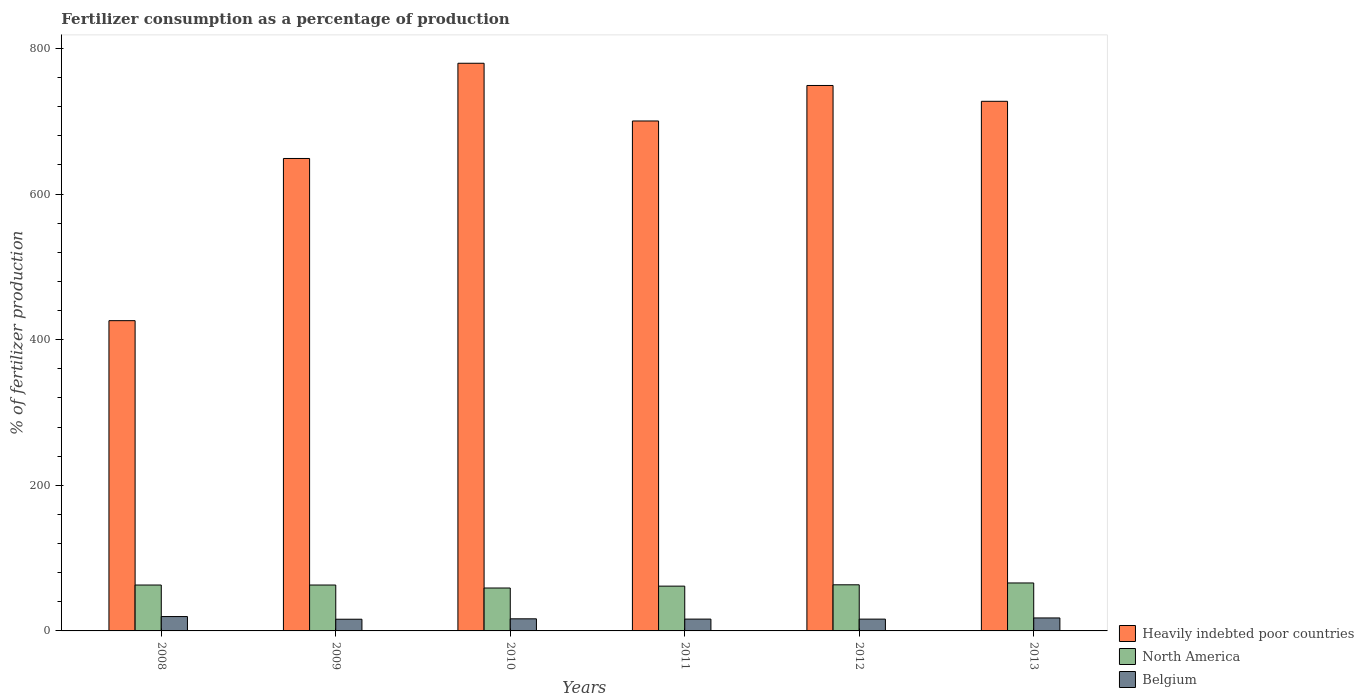How many groups of bars are there?
Make the answer very short. 6. Are the number of bars on each tick of the X-axis equal?
Offer a terse response. Yes. How many bars are there on the 2nd tick from the right?
Give a very brief answer. 3. What is the percentage of fertilizers consumed in Belgium in 2008?
Keep it short and to the point. 19.73. Across all years, what is the maximum percentage of fertilizers consumed in North America?
Ensure brevity in your answer.  65.86. Across all years, what is the minimum percentage of fertilizers consumed in Belgium?
Make the answer very short. 16.07. What is the total percentage of fertilizers consumed in Heavily indebted poor countries in the graph?
Give a very brief answer. 4031.42. What is the difference between the percentage of fertilizers consumed in Belgium in 2009 and that in 2013?
Keep it short and to the point. -1.74. What is the difference between the percentage of fertilizers consumed in Belgium in 2011 and the percentage of fertilizers consumed in North America in 2008?
Your response must be concise. -46.8. What is the average percentage of fertilizers consumed in Heavily indebted poor countries per year?
Offer a very short reply. 671.9. In the year 2008, what is the difference between the percentage of fertilizers consumed in Heavily indebted poor countries and percentage of fertilizers consumed in North America?
Your response must be concise. 363.08. What is the ratio of the percentage of fertilizers consumed in Belgium in 2012 to that in 2013?
Offer a very short reply. 0.91. Is the percentage of fertilizers consumed in Belgium in 2008 less than that in 2012?
Your response must be concise. No. Is the difference between the percentage of fertilizers consumed in Heavily indebted poor countries in 2008 and 2013 greater than the difference between the percentage of fertilizers consumed in North America in 2008 and 2013?
Give a very brief answer. No. What is the difference between the highest and the second highest percentage of fertilizers consumed in North America?
Make the answer very short. 2.53. What is the difference between the highest and the lowest percentage of fertilizers consumed in North America?
Your answer should be very brief. 6.93. Is the sum of the percentage of fertilizers consumed in Heavily indebted poor countries in 2008 and 2013 greater than the maximum percentage of fertilizers consumed in Belgium across all years?
Your answer should be compact. Yes. What does the 1st bar from the left in 2011 represents?
Your answer should be compact. Heavily indebted poor countries. What does the 3rd bar from the right in 2010 represents?
Your answer should be very brief. Heavily indebted poor countries. Are all the bars in the graph horizontal?
Your answer should be very brief. No. Does the graph contain grids?
Your answer should be compact. No. Where does the legend appear in the graph?
Give a very brief answer. Bottom right. How are the legend labels stacked?
Offer a terse response. Vertical. What is the title of the graph?
Keep it short and to the point. Fertilizer consumption as a percentage of production. What is the label or title of the X-axis?
Keep it short and to the point. Years. What is the label or title of the Y-axis?
Make the answer very short. % of fertilizer production. What is the % of fertilizer production in Heavily indebted poor countries in 2008?
Your answer should be compact. 426.11. What is the % of fertilizer production in North America in 2008?
Make the answer very short. 63.03. What is the % of fertilizer production of Belgium in 2008?
Offer a terse response. 19.73. What is the % of fertilizer production in Heavily indebted poor countries in 2009?
Make the answer very short. 648.85. What is the % of fertilizer production of North America in 2009?
Give a very brief answer. 63.04. What is the % of fertilizer production of Belgium in 2009?
Your answer should be compact. 16.07. What is the % of fertilizer production in Heavily indebted poor countries in 2010?
Provide a succinct answer. 779.62. What is the % of fertilizer production of North America in 2010?
Your answer should be compact. 58.93. What is the % of fertilizer production of Belgium in 2010?
Provide a succinct answer. 16.61. What is the % of fertilizer production of Heavily indebted poor countries in 2011?
Ensure brevity in your answer.  700.34. What is the % of fertilizer production in North America in 2011?
Offer a terse response. 61.51. What is the % of fertilizer production of Belgium in 2011?
Provide a succinct answer. 16.23. What is the % of fertilizer production of Heavily indebted poor countries in 2012?
Make the answer very short. 749.11. What is the % of fertilizer production of North America in 2012?
Your answer should be very brief. 63.33. What is the % of fertilizer production of Belgium in 2012?
Provide a short and direct response. 16.21. What is the % of fertilizer production in Heavily indebted poor countries in 2013?
Your answer should be very brief. 727.38. What is the % of fertilizer production in North America in 2013?
Your answer should be very brief. 65.86. What is the % of fertilizer production of Belgium in 2013?
Offer a terse response. 17.81. Across all years, what is the maximum % of fertilizer production in Heavily indebted poor countries?
Offer a very short reply. 779.62. Across all years, what is the maximum % of fertilizer production of North America?
Your answer should be very brief. 65.86. Across all years, what is the maximum % of fertilizer production of Belgium?
Ensure brevity in your answer.  19.73. Across all years, what is the minimum % of fertilizer production of Heavily indebted poor countries?
Make the answer very short. 426.11. Across all years, what is the minimum % of fertilizer production in North America?
Your answer should be very brief. 58.93. Across all years, what is the minimum % of fertilizer production of Belgium?
Make the answer very short. 16.07. What is the total % of fertilizer production of Heavily indebted poor countries in the graph?
Provide a short and direct response. 4031.42. What is the total % of fertilizer production of North America in the graph?
Your response must be concise. 375.7. What is the total % of fertilizer production in Belgium in the graph?
Give a very brief answer. 102.66. What is the difference between the % of fertilizer production of Heavily indebted poor countries in 2008 and that in 2009?
Keep it short and to the point. -222.75. What is the difference between the % of fertilizer production of North America in 2008 and that in 2009?
Ensure brevity in your answer.  -0.01. What is the difference between the % of fertilizer production of Belgium in 2008 and that in 2009?
Keep it short and to the point. 3.66. What is the difference between the % of fertilizer production of Heavily indebted poor countries in 2008 and that in 2010?
Your answer should be very brief. -353.51. What is the difference between the % of fertilizer production of North America in 2008 and that in 2010?
Your response must be concise. 4.1. What is the difference between the % of fertilizer production in Belgium in 2008 and that in 2010?
Provide a short and direct response. 3.12. What is the difference between the % of fertilizer production of Heavily indebted poor countries in 2008 and that in 2011?
Keep it short and to the point. -274.24. What is the difference between the % of fertilizer production of North America in 2008 and that in 2011?
Provide a succinct answer. 1.51. What is the difference between the % of fertilizer production in Belgium in 2008 and that in 2011?
Your answer should be very brief. 3.5. What is the difference between the % of fertilizer production in Heavily indebted poor countries in 2008 and that in 2012?
Give a very brief answer. -323. What is the difference between the % of fertilizer production of North America in 2008 and that in 2012?
Your response must be concise. -0.31. What is the difference between the % of fertilizer production in Belgium in 2008 and that in 2012?
Provide a short and direct response. 3.52. What is the difference between the % of fertilizer production in Heavily indebted poor countries in 2008 and that in 2013?
Ensure brevity in your answer.  -301.27. What is the difference between the % of fertilizer production in North America in 2008 and that in 2013?
Offer a terse response. -2.84. What is the difference between the % of fertilizer production in Belgium in 2008 and that in 2013?
Provide a short and direct response. 1.92. What is the difference between the % of fertilizer production of Heavily indebted poor countries in 2009 and that in 2010?
Ensure brevity in your answer.  -130.77. What is the difference between the % of fertilizer production of North America in 2009 and that in 2010?
Offer a terse response. 4.11. What is the difference between the % of fertilizer production of Belgium in 2009 and that in 2010?
Offer a very short reply. -0.54. What is the difference between the % of fertilizer production of Heavily indebted poor countries in 2009 and that in 2011?
Give a very brief answer. -51.49. What is the difference between the % of fertilizer production of North America in 2009 and that in 2011?
Make the answer very short. 1.52. What is the difference between the % of fertilizer production in Belgium in 2009 and that in 2011?
Offer a very short reply. -0.16. What is the difference between the % of fertilizer production of Heavily indebted poor countries in 2009 and that in 2012?
Offer a terse response. -100.26. What is the difference between the % of fertilizer production in North America in 2009 and that in 2012?
Your answer should be compact. -0.3. What is the difference between the % of fertilizer production in Belgium in 2009 and that in 2012?
Provide a succinct answer. -0.14. What is the difference between the % of fertilizer production of Heavily indebted poor countries in 2009 and that in 2013?
Make the answer very short. -78.52. What is the difference between the % of fertilizer production in North America in 2009 and that in 2013?
Offer a very short reply. -2.83. What is the difference between the % of fertilizer production of Belgium in 2009 and that in 2013?
Your response must be concise. -1.74. What is the difference between the % of fertilizer production in Heavily indebted poor countries in 2010 and that in 2011?
Keep it short and to the point. 79.28. What is the difference between the % of fertilizer production in North America in 2010 and that in 2011?
Your answer should be very brief. -2.58. What is the difference between the % of fertilizer production in Belgium in 2010 and that in 2011?
Your answer should be very brief. 0.38. What is the difference between the % of fertilizer production in Heavily indebted poor countries in 2010 and that in 2012?
Your response must be concise. 30.51. What is the difference between the % of fertilizer production of North America in 2010 and that in 2012?
Ensure brevity in your answer.  -4.4. What is the difference between the % of fertilizer production in Belgium in 2010 and that in 2012?
Your answer should be very brief. 0.4. What is the difference between the % of fertilizer production of Heavily indebted poor countries in 2010 and that in 2013?
Your answer should be very brief. 52.25. What is the difference between the % of fertilizer production of North America in 2010 and that in 2013?
Your answer should be very brief. -6.93. What is the difference between the % of fertilizer production of Belgium in 2010 and that in 2013?
Make the answer very short. -1.2. What is the difference between the % of fertilizer production of Heavily indebted poor countries in 2011 and that in 2012?
Your response must be concise. -48.77. What is the difference between the % of fertilizer production of North America in 2011 and that in 2012?
Your answer should be compact. -1.82. What is the difference between the % of fertilizer production of Belgium in 2011 and that in 2012?
Provide a short and direct response. 0.02. What is the difference between the % of fertilizer production of Heavily indebted poor countries in 2011 and that in 2013?
Offer a terse response. -27.03. What is the difference between the % of fertilizer production of North America in 2011 and that in 2013?
Keep it short and to the point. -4.35. What is the difference between the % of fertilizer production in Belgium in 2011 and that in 2013?
Your response must be concise. -1.58. What is the difference between the % of fertilizer production of Heavily indebted poor countries in 2012 and that in 2013?
Keep it short and to the point. 21.73. What is the difference between the % of fertilizer production of North America in 2012 and that in 2013?
Ensure brevity in your answer.  -2.53. What is the difference between the % of fertilizer production in Belgium in 2012 and that in 2013?
Keep it short and to the point. -1.6. What is the difference between the % of fertilizer production in Heavily indebted poor countries in 2008 and the % of fertilizer production in North America in 2009?
Offer a very short reply. 363.07. What is the difference between the % of fertilizer production of Heavily indebted poor countries in 2008 and the % of fertilizer production of Belgium in 2009?
Give a very brief answer. 410.04. What is the difference between the % of fertilizer production in North America in 2008 and the % of fertilizer production in Belgium in 2009?
Your answer should be compact. 46.96. What is the difference between the % of fertilizer production of Heavily indebted poor countries in 2008 and the % of fertilizer production of North America in 2010?
Make the answer very short. 367.18. What is the difference between the % of fertilizer production in Heavily indebted poor countries in 2008 and the % of fertilizer production in Belgium in 2010?
Offer a terse response. 409.5. What is the difference between the % of fertilizer production of North America in 2008 and the % of fertilizer production of Belgium in 2010?
Offer a very short reply. 46.41. What is the difference between the % of fertilizer production in Heavily indebted poor countries in 2008 and the % of fertilizer production in North America in 2011?
Keep it short and to the point. 364.6. What is the difference between the % of fertilizer production in Heavily indebted poor countries in 2008 and the % of fertilizer production in Belgium in 2011?
Offer a very short reply. 409.88. What is the difference between the % of fertilizer production of North America in 2008 and the % of fertilizer production of Belgium in 2011?
Keep it short and to the point. 46.8. What is the difference between the % of fertilizer production in Heavily indebted poor countries in 2008 and the % of fertilizer production in North America in 2012?
Your answer should be compact. 362.77. What is the difference between the % of fertilizer production in Heavily indebted poor countries in 2008 and the % of fertilizer production in Belgium in 2012?
Give a very brief answer. 409.9. What is the difference between the % of fertilizer production in North America in 2008 and the % of fertilizer production in Belgium in 2012?
Offer a very short reply. 46.82. What is the difference between the % of fertilizer production in Heavily indebted poor countries in 2008 and the % of fertilizer production in North America in 2013?
Your answer should be compact. 360.25. What is the difference between the % of fertilizer production in Heavily indebted poor countries in 2008 and the % of fertilizer production in Belgium in 2013?
Ensure brevity in your answer.  408.3. What is the difference between the % of fertilizer production of North America in 2008 and the % of fertilizer production of Belgium in 2013?
Provide a succinct answer. 45.22. What is the difference between the % of fertilizer production in Heavily indebted poor countries in 2009 and the % of fertilizer production in North America in 2010?
Offer a very short reply. 589.92. What is the difference between the % of fertilizer production in Heavily indebted poor countries in 2009 and the % of fertilizer production in Belgium in 2010?
Offer a terse response. 632.24. What is the difference between the % of fertilizer production in North America in 2009 and the % of fertilizer production in Belgium in 2010?
Provide a succinct answer. 46.42. What is the difference between the % of fertilizer production in Heavily indebted poor countries in 2009 and the % of fertilizer production in North America in 2011?
Your response must be concise. 587.34. What is the difference between the % of fertilizer production in Heavily indebted poor countries in 2009 and the % of fertilizer production in Belgium in 2011?
Your response must be concise. 632.62. What is the difference between the % of fertilizer production in North America in 2009 and the % of fertilizer production in Belgium in 2011?
Offer a terse response. 46.81. What is the difference between the % of fertilizer production of Heavily indebted poor countries in 2009 and the % of fertilizer production of North America in 2012?
Offer a very short reply. 585.52. What is the difference between the % of fertilizer production of Heavily indebted poor countries in 2009 and the % of fertilizer production of Belgium in 2012?
Ensure brevity in your answer.  632.65. What is the difference between the % of fertilizer production in North America in 2009 and the % of fertilizer production in Belgium in 2012?
Make the answer very short. 46.83. What is the difference between the % of fertilizer production in Heavily indebted poor countries in 2009 and the % of fertilizer production in North America in 2013?
Offer a very short reply. 582.99. What is the difference between the % of fertilizer production in Heavily indebted poor countries in 2009 and the % of fertilizer production in Belgium in 2013?
Keep it short and to the point. 631.04. What is the difference between the % of fertilizer production of North America in 2009 and the % of fertilizer production of Belgium in 2013?
Offer a very short reply. 45.23. What is the difference between the % of fertilizer production in Heavily indebted poor countries in 2010 and the % of fertilizer production in North America in 2011?
Give a very brief answer. 718.11. What is the difference between the % of fertilizer production in Heavily indebted poor countries in 2010 and the % of fertilizer production in Belgium in 2011?
Provide a succinct answer. 763.39. What is the difference between the % of fertilizer production in North America in 2010 and the % of fertilizer production in Belgium in 2011?
Provide a succinct answer. 42.7. What is the difference between the % of fertilizer production of Heavily indebted poor countries in 2010 and the % of fertilizer production of North America in 2012?
Provide a succinct answer. 716.29. What is the difference between the % of fertilizer production in Heavily indebted poor countries in 2010 and the % of fertilizer production in Belgium in 2012?
Make the answer very short. 763.42. What is the difference between the % of fertilizer production in North America in 2010 and the % of fertilizer production in Belgium in 2012?
Offer a terse response. 42.72. What is the difference between the % of fertilizer production in Heavily indebted poor countries in 2010 and the % of fertilizer production in North America in 2013?
Give a very brief answer. 713.76. What is the difference between the % of fertilizer production in Heavily indebted poor countries in 2010 and the % of fertilizer production in Belgium in 2013?
Your response must be concise. 761.81. What is the difference between the % of fertilizer production of North America in 2010 and the % of fertilizer production of Belgium in 2013?
Keep it short and to the point. 41.12. What is the difference between the % of fertilizer production in Heavily indebted poor countries in 2011 and the % of fertilizer production in North America in 2012?
Your answer should be very brief. 637.01. What is the difference between the % of fertilizer production of Heavily indebted poor countries in 2011 and the % of fertilizer production of Belgium in 2012?
Keep it short and to the point. 684.14. What is the difference between the % of fertilizer production in North America in 2011 and the % of fertilizer production in Belgium in 2012?
Make the answer very short. 45.3. What is the difference between the % of fertilizer production of Heavily indebted poor countries in 2011 and the % of fertilizer production of North America in 2013?
Offer a very short reply. 634.48. What is the difference between the % of fertilizer production in Heavily indebted poor countries in 2011 and the % of fertilizer production in Belgium in 2013?
Ensure brevity in your answer.  682.53. What is the difference between the % of fertilizer production in North America in 2011 and the % of fertilizer production in Belgium in 2013?
Provide a short and direct response. 43.7. What is the difference between the % of fertilizer production in Heavily indebted poor countries in 2012 and the % of fertilizer production in North America in 2013?
Ensure brevity in your answer.  683.25. What is the difference between the % of fertilizer production in Heavily indebted poor countries in 2012 and the % of fertilizer production in Belgium in 2013?
Your response must be concise. 731.3. What is the difference between the % of fertilizer production in North America in 2012 and the % of fertilizer production in Belgium in 2013?
Make the answer very short. 45.52. What is the average % of fertilizer production in Heavily indebted poor countries per year?
Your answer should be very brief. 671.9. What is the average % of fertilizer production of North America per year?
Keep it short and to the point. 62.62. What is the average % of fertilizer production in Belgium per year?
Offer a terse response. 17.11. In the year 2008, what is the difference between the % of fertilizer production in Heavily indebted poor countries and % of fertilizer production in North America?
Provide a short and direct response. 363.08. In the year 2008, what is the difference between the % of fertilizer production of Heavily indebted poor countries and % of fertilizer production of Belgium?
Your response must be concise. 406.38. In the year 2008, what is the difference between the % of fertilizer production of North America and % of fertilizer production of Belgium?
Make the answer very short. 43.3. In the year 2009, what is the difference between the % of fertilizer production in Heavily indebted poor countries and % of fertilizer production in North America?
Ensure brevity in your answer.  585.82. In the year 2009, what is the difference between the % of fertilizer production in Heavily indebted poor countries and % of fertilizer production in Belgium?
Provide a succinct answer. 632.78. In the year 2009, what is the difference between the % of fertilizer production in North America and % of fertilizer production in Belgium?
Keep it short and to the point. 46.97. In the year 2010, what is the difference between the % of fertilizer production of Heavily indebted poor countries and % of fertilizer production of North America?
Give a very brief answer. 720.69. In the year 2010, what is the difference between the % of fertilizer production of Heavily indebted poor countries and % of fertilizer production of Belgium?
Your answer should be very brief. 763.01. In the year 2010, what is the difference between the % of fertilizer production in North America and % of fertilizer production in Belgium?
Ensure brevity in your answer.  42.32. In the year 2011, what is the difference between the % of fertilizer production of Heavily indebted poor countries and % of fertilizer production of North America?
Provide a short and direct response. 638.83. In the year 2011, what is the difference between the % of fertilizer production in Heavily indebted poor countries and % of fertilizer production in Belgium?
Keep it short and to the point. 684.11. In the year 2011, what is the difference between the % of fertilizer production of North America and % of fertilizer production of Belgium?
Offer a terse response. 45.28. In the year 2012, what is the difference between the % of fertilizer production in Heavily indebted poor countries and % of fertilizer production in North America?
Provide a short and direct response. 685.78. In the year 2012, what is the difference between the % of fertilizer production of Heavily indebted poor countries and % of fertilizer production of Belgium?
Your answer should be compact. 732.9. In the year 2012, what is the difference between the % of fertilizer production in North America and % of fertilizer production in Belgium?
Your answer should be very brief. 47.13. In the year 2013, what is the difference between the % of fertilizer production of Heavily indebted poor countries and % of fertilizer production of North America?
Provide a succinct answer. 661.52. In the year 2013, what is the difference between the % of fertilizer production in Heavily indebted poor countries and % of fertilizer production in Belgium?
Make the answer very short. 709.57. In the year 2013, what is the difference between the % of fertilizer production of North America and % of fertilizer production of Belgium?
Ensure brevity in your answer.  48.05. What is the ratio of the % of fertilizer production in Heavily indebted poor countries in 2008 to that in 2009?
Ensure brevity in your answer.  0.66. What is the ratio of the % of fertilizer production in North America in 2008 to that in 2009?
Your answer should be compact. 1. What is the ratio of the % of fertilizer production in Belgium in 2008 to that in 2009?
Make the answer very short. 1.23. What is the ratio of the % of fertilizer production of Heavily indebted poor countries in 2008 to that in 2010?
Keep it short and to the point. 0.55. What is the ratio of the % of fertilizer production in North America in 2008 to that in 2010?
Keep it short and to the point. 1.07. What is the ratio of the % of fertilizer production in Belgium in 2008 to that in 2010?
Your response must be concise. 1.19. What is the ratio of the % of fertilizer production of Heavily indebted poor countries in 2008 to that in 2011?
Provide a succinct answer. 0.61. What is the ratio of the % of fertilizer production in North America in 2008 to that in 2011?
Your answer should be very brief. 1.02. What is the ratio of the % of fertilizer production in Belgium in 2008 to that in 2011?
Provide a succinct answer. 1.22. What is the ratio of the % of fertilizer production in Heavily indebted poor countries in 2008 to that in 2012?
Provide a succinct answer. 0.57. What is the ratio of the % of fertilizer production in North America in 2008 to that in 2012?
Your response must be concise. 1. What is the ratio of the % of fertilizer production of Belgium in 2008 to that in 2012?
Your answer should be compact. 1.22. What is the ratio of the % of fertilizer production of Heavily indebted poor countries in 2008 to that in 2013?
Provide a short and direct response. 0.59. What is the ratio of the % of fertilizer production of North America in 2008 to that in 2013?
Your answer should be very brief. 0.96. What is the ratio of the % of fertilizer production of Belgium in 2008 to that in 2013?
Your response must be concise. 1.11. What is the ratio of the % of fertilizer production in Heavily indebted poor countries in 2009 to that in 2010?
Give a very brief answer. 0.83. What is the ratio of the % of fertilizer production in North America in 2009 to that in 2010?
Make the answer very short. 1.07. What is the ratio of the % of fertilizer production of Belgium in 2009 to that in 2010?
Make the answer very short. 0.97. What is the ratio of the % of fertilizer production of Heavily indebted poor countries in 2009 to that in 2011?
Keep it short and to the point. 0.93. What is the ratio of the % of fertilizer production of North America in 2009 to that in 2011?
Your response must be concise. 1.02. What is the ratio of the % of fertilizer production of Heavily indebted poor countries in 2009 to that in 2012?
Offer a terse response. 0.87. What is the ratio of the % of fertilizer production of Heavily indebted poor countries in 2009 to that in 2013?
Make the answer very short. 0.89. What is the ratio of the % of fertilizer production in North America in 2009 to that in 2013?
Your response must be concise. 0.96. What is the ratio of the % of fertilizer production of Belgium in 2009 to that in 2013?
Offer a very short reply. 0.9. What is the ratio of the % of fertilizer production in Heavily indebted poor countries in 2010 to that in 2011?
Provide a succinct answer. 1.11. What is the ratio of the % of fertilizer production in North America in 2010 to that in 2011?
Make the answer very short. 0.96. What is the ratio of the % of fertilizer production of Belgium in 2010 to that in 2011?
Your answer should be compact. 1.02. What is the ratio of the % of fertilizer production in Heavily indebted poor countries in 2010 to that in 2012?
Make the answer very short. 1.04. What is the ratio of the % of fertilizer production in North America in 2010 to that in 2012?
Your response must be concise. 0.93. What is the ratio of the % of fertilizer production of Belgium in 2010 to that in 2012?
Provide a succinct answer. 1.02. What is the ratio of the % of fertilizer production in Heavily indebted poor countries in 2010 to that in 2013?
Keep it short and to the point. 1.07. What is the ratio of the % of fertilizer production of North America in 2010 to that in 2013?
Give a very brief answer. 0.89. What is the ratio of the % of fertilizer production of Belgium in 2010 to that in 2013?
Offer a very short reply. 0.93. What is the ratio of the % of fertilizer production in Heavily indebted poor countries in 2011 to that in 2012?
Provide a succinct answer. 0.93. What is the ratio of the % of fertilizer production of North America in 2011 to that in 2012?
Ensure brevity in your answer.  0.97. What is the ratio of the % of fertilizer production of Heavily indebted poor countries in 2011 to that in 2013?
Offer a terse response. 0.96. What is the ratio of the % of fertilizer production in North America in 2011 to that in 2013?
Provide a succinct answer. 0.93. What is the ratio of the % of fertilizer production in Belgium in 2011 to that in 2013?
Make the answer very short. 0.91. What is the ratio of the % of fertilizer production of Heavily indebted poor countries in 2012 to that in 2013?
Your answer should be very brief. 1.03. What is the ratio of the % of fertilizer production of North America in 2012 to that in 2013?
Give a very brief answer. 0.96. What is the ratio of the % of fertilizer production of Belgium in 2012 to that in 2013?
Give a very brief answer. 0.91. What is the difference between the highest and the second highest % of fertilizer production in Heavily indebted poor countries?
Your answer should be compact. 30.51. What is the difference between the highest and the second highest % of fertilizer production in North America?
Offer a terse response. 2.53. What is the difference between the highest and the second highest % of fertilizer production in Belgium?
Your response must be concise. 1.92. What is the difference between the highest and the lowest % of fertilizer production in Heavily indebted poor countries?
Make the answer very short. 353.51. What is the difference between the highest and the lowest % of fertilizer production in North America?
Your answer should be compact. 6.93. What is the difference between the highest and the lowest % of fertilizer production of Belgium?
Offer a very short reply. 3.66. 